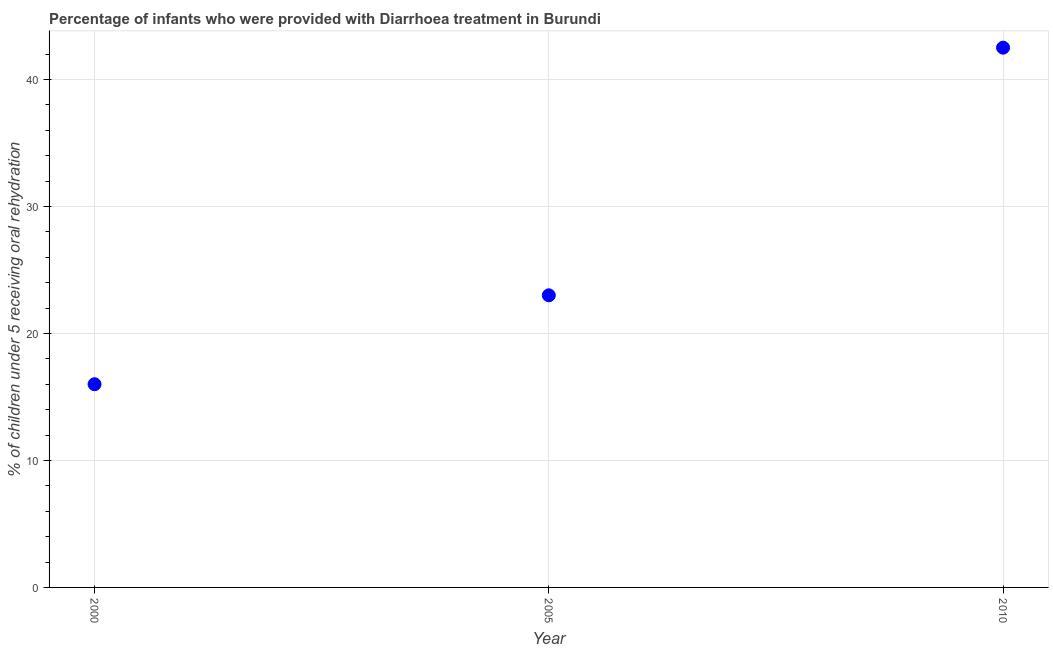What is the percentage of children who were provided with treatment diarrhoea in 2010?
Your response must be concise. 42.5. Across all years, what is the maximum percentage of children who were provided with treatment diarrhoea?
Provide a short and direct response. 42.5. In which year was the percentage of children who were provided with treatment diarrhoea minimum?
Your response must be concise. 2000. What is the sum of the percentage of children who were provided with treatment diarrhoea?
Offer a terse response. 81.5. What is the difference between the percentage of children who were provided with treatment diarrhoea in 2000 and 2005?
Ensure brevity in your answer.  -7. What is the average percentage of children who were provided with treatment diarrhoea per year?
Your response must be concise. 27.17. What is the median percentage of children who were provided with treatment diarrhoea?
Offer a very short reply. 23. What is the ratio of the percentage of children who were provided with treatment diarrhoea in 2005 to that in 2010?
Your answer should be compact. 0.54. Is the percentage of children who were provided with treatment diarrhoea in 2000 less than that in 2010?
Make the answer very short. Yes. Does the percentage of children who were provided with treatment diarrhoea monotonically increase over the years?
Make the answer very short. Yes. How many years are there in the graph?
Provide a short and direct response. 3. What is the title of the graph?
Offer a very short reply. Percentage of infants who were provided with Diarrhoea treatment in Burundi. What is the label or title of the X-axis?
Offer a very short reply. Year. What is the label or title of the Y-axis?
Keep it short and to the point. % of children under 5 receiving oral rehydration. What is the % of children under 5 receiving oral rehydration in 2010?
Offer a very short reply. 42.5. What is the difference between the % of children under 5 receiving oral rehydration in 2000 and 2005?
Offer a very short reply. -7. What is the difference between the % of children under 5 receiving oral rehydration in 2000 and 2010?
Offer a terse response. -26.5. What is the difference between the % of children under 5 receiving oral rehydration in 2005 and 2010?
Keep it short and to the point. -19.5. What is the ratio of the % of children under 5 receiving oral rehydration in 2000 to that in 2005?
Make the answer very short. 0.7. What is the ratio of the % of children under 5 receiving oral rehydration in 2000 to that in 2010?
Provide a short and direct response. 0.38. What is the ratio of the % of children under 5 receiving oral rehydration in 2005 to that in 2010?
Your answer should be very brief. 0.54. 